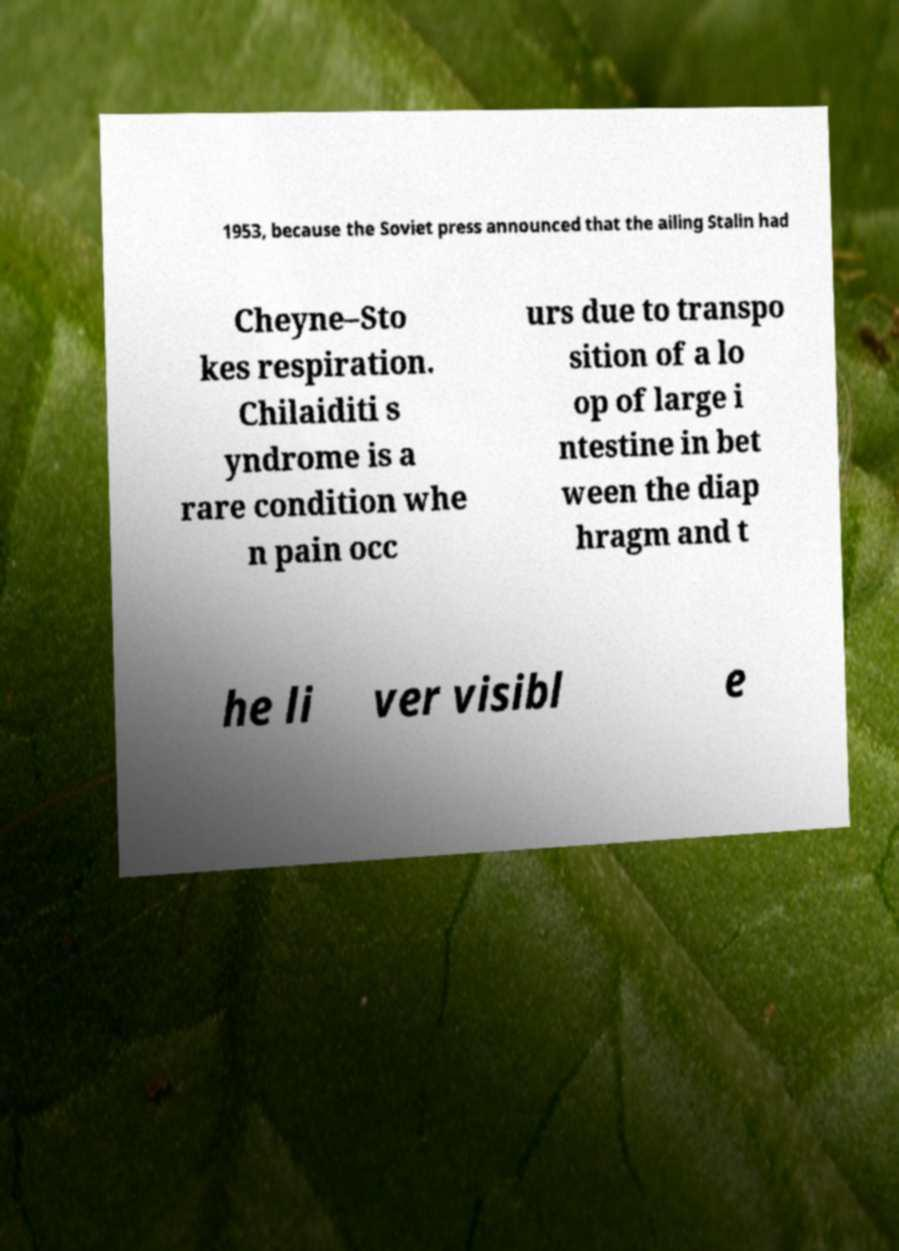What messages or text are displayed in this image? I need them in a readable, typed format. 1953, because the Soviet press announced that the ailing Stalin had Cheyne–Sto kes respiration. Chilaiditi s yndrome is a rare condition whe n pain occ urs due to transpo sition of a lo op of large i ntestine in bet ween the diap hragm and t he li ver visibl e 